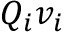<formula> <loc_0><loc_0><loc_500><loc_500>Q _ { i } v _ { i }</formula> 